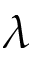Convert formula to latex. <formula><loc_0><loc_0><loc_500><loc_500>\lambda</formula> 